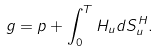Convert formula to latex. <formula><loc_0><loc_0><loc_500><loc_500>g = p + \int _ { 0 } ^ { T } H _ { u } d S ^ { H } _ { u } .</formula> 